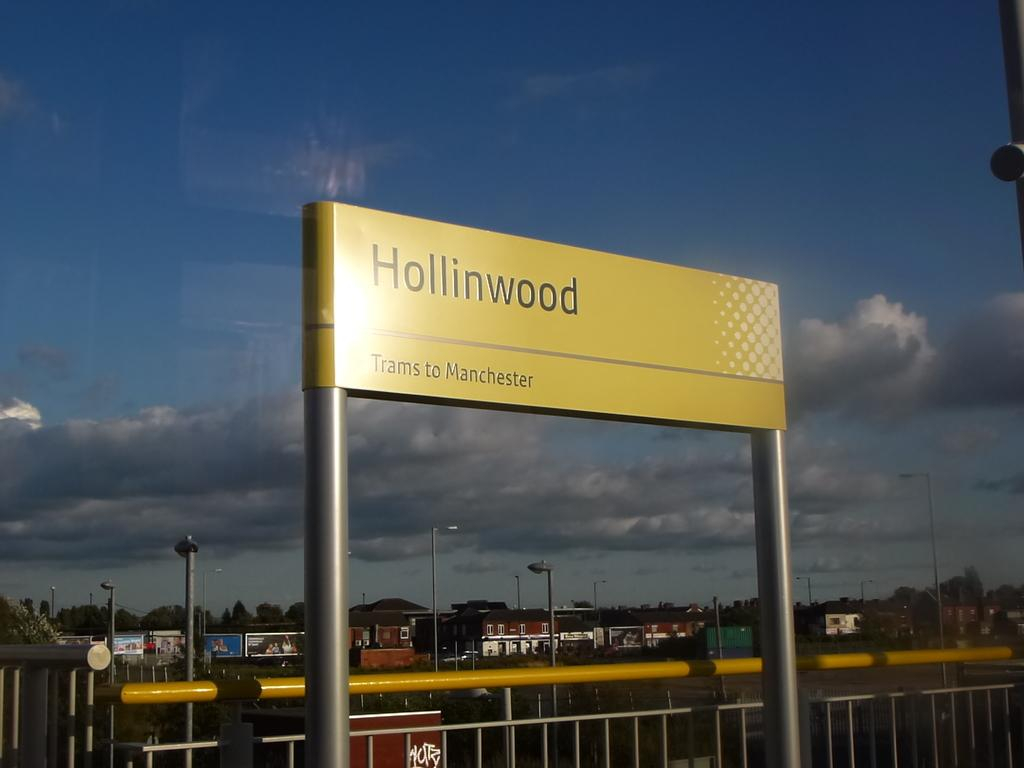<image>
Share a concise interpretation of the image provided. A large yellow sign above a fence says Hollinwood. 